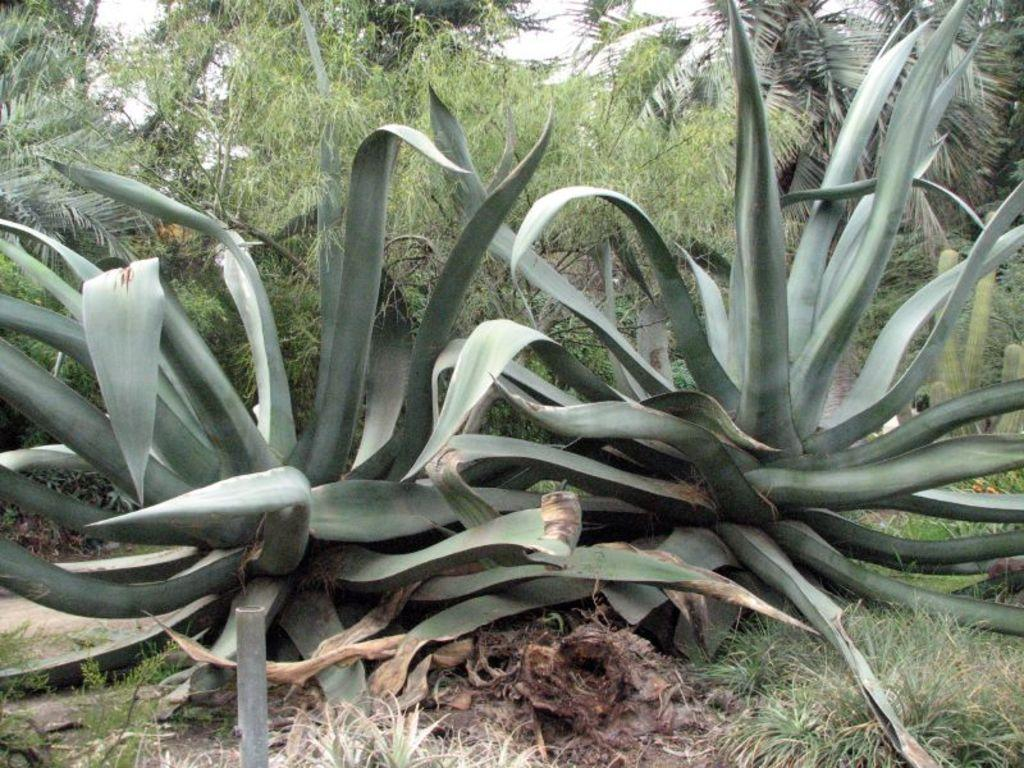What type of vegetation can be seen in the image? There is grass and trees in the image. Are there any specific plants mentioned in the facts? Yes, there are two agave plants in the image. What part of the natural environment is visible in the image? The sky is visible in the image. Can you tell me how many times the hose is used in the image? There is no hose present in the image, so it cannot be used or counted. What type of war is depicted in the image? There is no depiction of war in the image; it features natural elements like grass, trees, and agave plants. 